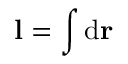<formula> <loc_0><loc_0><loc_500><loc_500>l = \int d r \,</formula> 